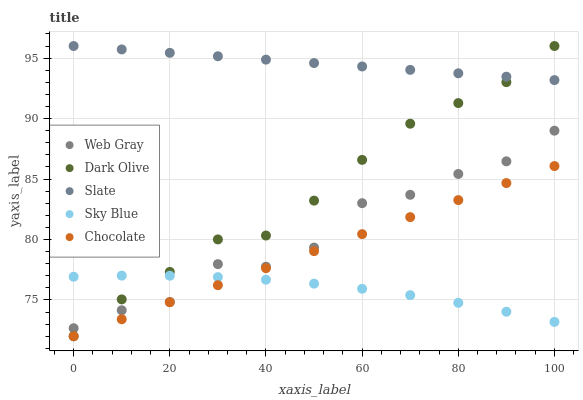Does Sky Blue have the minimum area under the curve?
Answer yes or no. Yes. Does Slate have the maximum area under the curve?
Answer yes or no. Yes. Does Slate have the minimum area under the curve?
Answer yes or no. No. Does Sky Blue have the maximum area under the curve?
Answer yes or no. No. Is Chocolate the smoothest?
Answer yes or no. Yes. Is Web Gray the roughest?
Answer yes or no. Yes. Is Sky Blue the smoothest?
Answer yes or no. No. Is Sky Blue the roughest?
Answer yes or no. No. Does Dark Olive have the lowest value?
Answer yes or no. Yes. Does Sky Blue have the lowest value?
Answer yes or no. No. Does Slate have the highest value?
Answer yes or no. Yes. Does Sky Blue have the highest value?
Answer yes or no. No. Is Sky Blue less than Slate?
Answer yes or no. Yes. Is Slate greater than Web Gray?
Answer yes or no. Yes. Does Sky Blue intersect Dark Olive?
Answer yes or no. Yes. Is Sky Blue less than Dark Olive?
Answer yes or no. No. Is Sky Blue greater than Dark Olive?
Answer yes or no. No. Does Sky Blue intersect Slate?
Answer yes or no. No. 